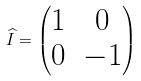Convert formula to latex. <formula><loc_0><loc_0><loc_500><loc_500>\widehat { I } = \begin{pmatrix} 1 & 0 \\ 0 & - 1 \end{pmatrix}</formula> 